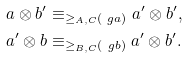Convert formula to latex. <formula><loc_0><loc_0><loc_500><loc_500>a \otimes b ^ { \prime } & \equiv _ { \geq _ { A , C } ( \ g a ) } a ^ { \prime } \otimes b ^ { \prime } , \\ a ^ { \prime } \otimes b & \equiv _ { \geq _ { B , C } ( \ g b ) } a ^ { \prime } \otimes b ^ { \prime } .</formula> 